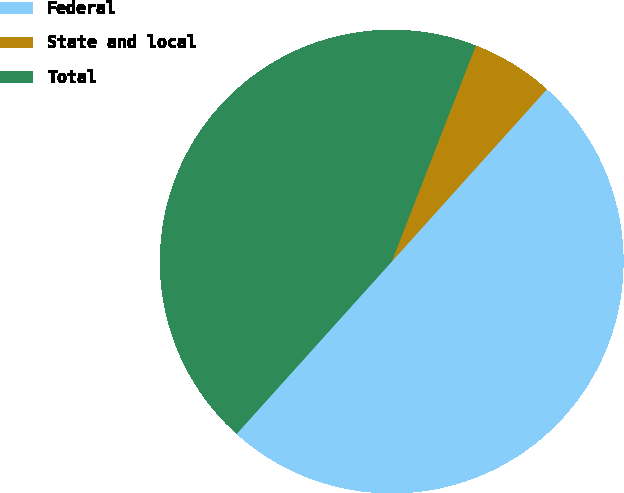Convert chart. <chart><loc_0><loc_0><loc_500><loc_500><pie_chart><fcel>Federal<fcel>State and local<fcel>Total<nl><fcel>50.0%<fcel>5.76%<fcel>44.24%<nl></chart> 